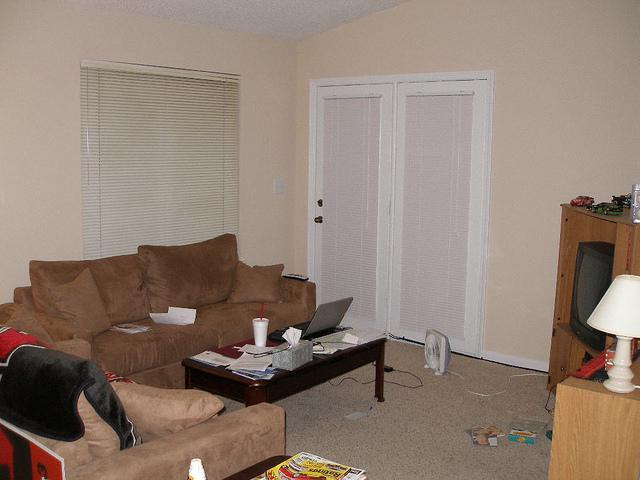What poses the biggest threat for a person to trip on? Please explain your reasoning. cords. A living room type area is shown with cords strewn across the floor. people trip on cords. 